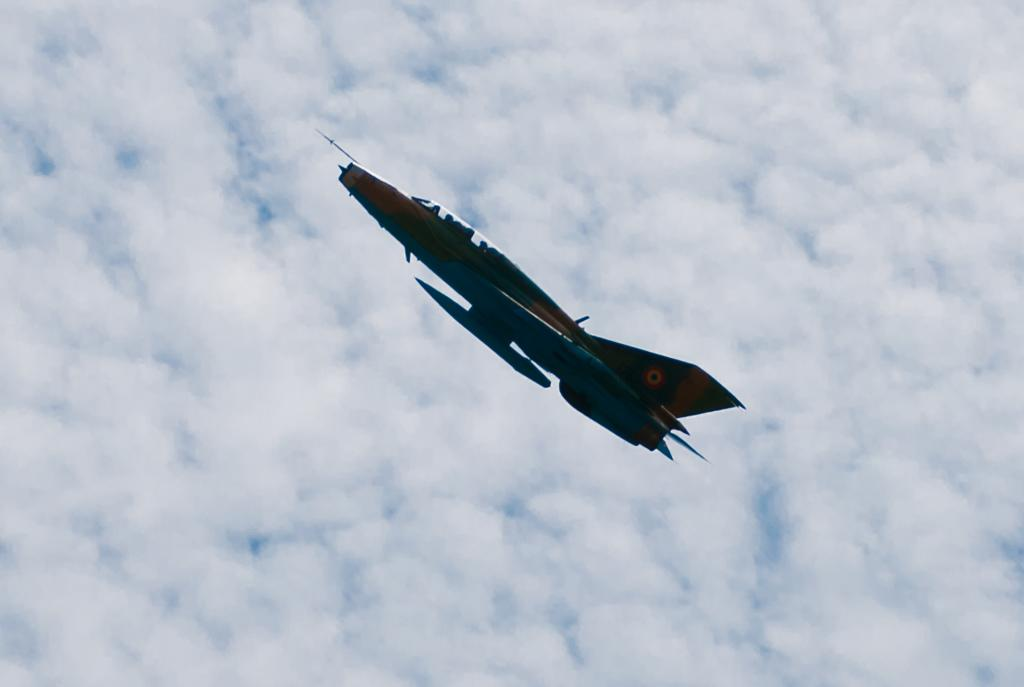What is the main subject of the image? The main subject of the image is a plane. What is the plane doing in the image? The plane is flying in the air. What can be seen in the background of the image? There is sky visible in the background of the image. What is the condition of the sky in the image? Clouds are present in the sky. What type of business is being conducted in the image? There is no indication of any business being conducted in the image; it simply shows a plane flying in the sky. Can you tell me how many ice cubes are floating in the sky in the image? There are no ice cubes present in the image; it features a plane flying in the sky with clouds. 